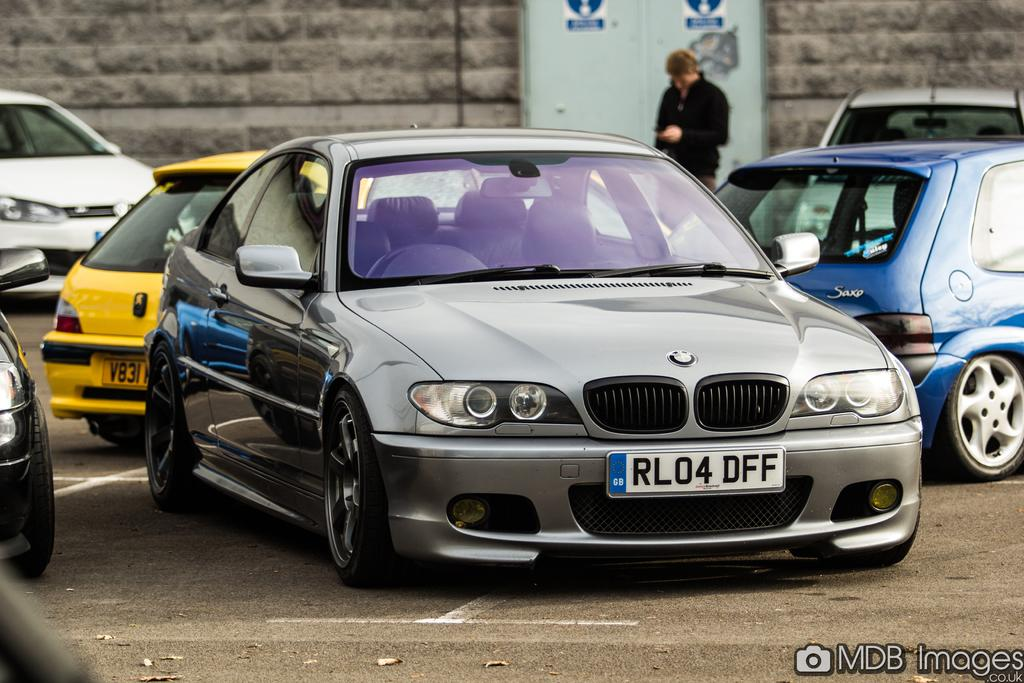<image>
Write a terse but informative summary of the picture. a grey BMW with the license plate RL04 DFF 